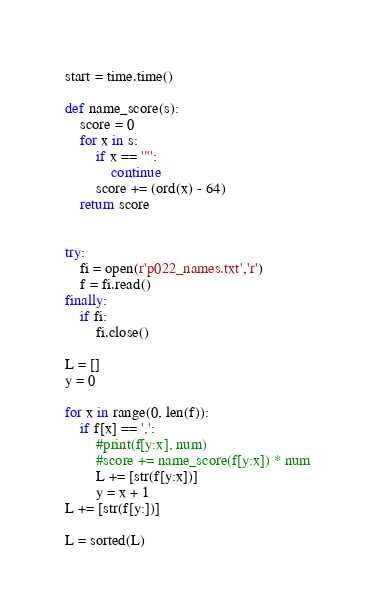<code> <loc_0><loc_0><loc_500><loc_500><_Python_>start = time.time()

def name_score(s):
    score = 0
    for x in s:
        if x == '"':
            continue
        score += (ord(x) - 64)
    return score


try:
    fi = open(r'p022_names.txt','r')
    f = fi.read()
finally:
    if fi:
        fi.close()

L = []
y = 0

for x in range(0, len(f)):
    if f[x] == ',':
        #print(f[y:x], num)
        #score += name_score(f[y:x]) * num
        L += [str(f[y:x])]
        y = x + 1
L += [str(f[y:])]

L = sorted(L)</code> 